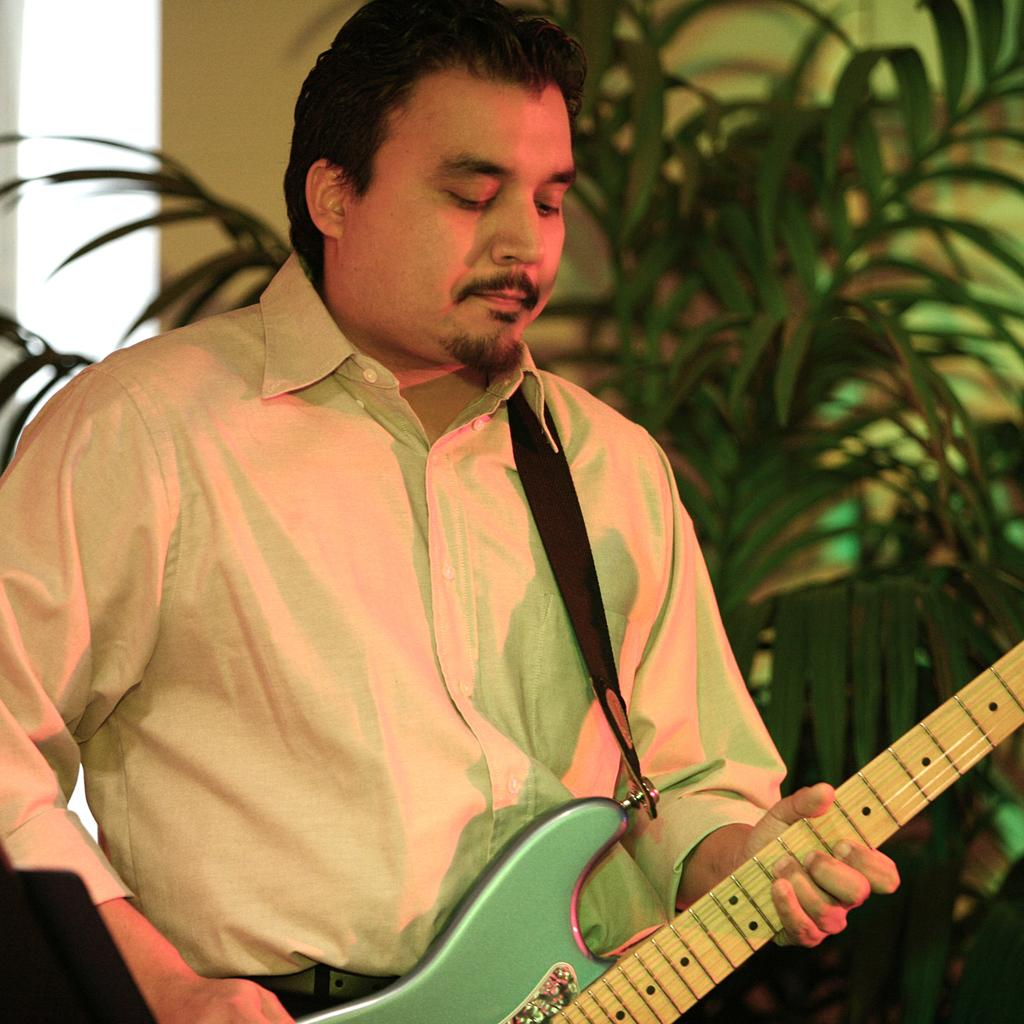What is the man in the image holding? The man is holding a guitar. Can you describe the background of the image? There is a plant in the background of the image. Where is the shop located in the image? There is no shop present in the image. What type of basin can be seen in the image? There is no basin present in the image. 